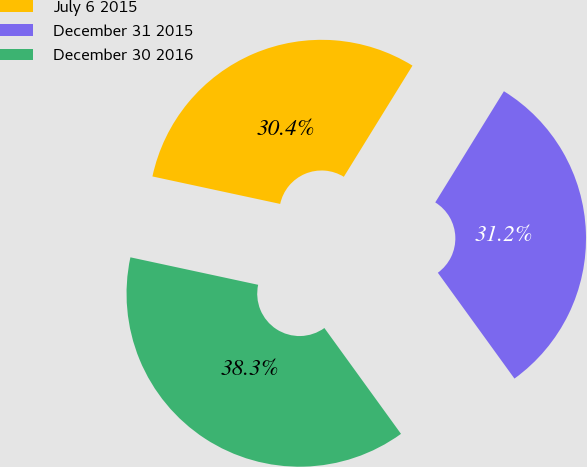Convert chart to OTSL. <chart><loc_0><loc_0><loc_500><loc_500><pie_chart><fcel>July 6 2015<fcel>December 31 2015<fcel>December 30 2016<nl><fcel>30.43%<fcel>31.22%<fcel>38.34%<nl></chart> 